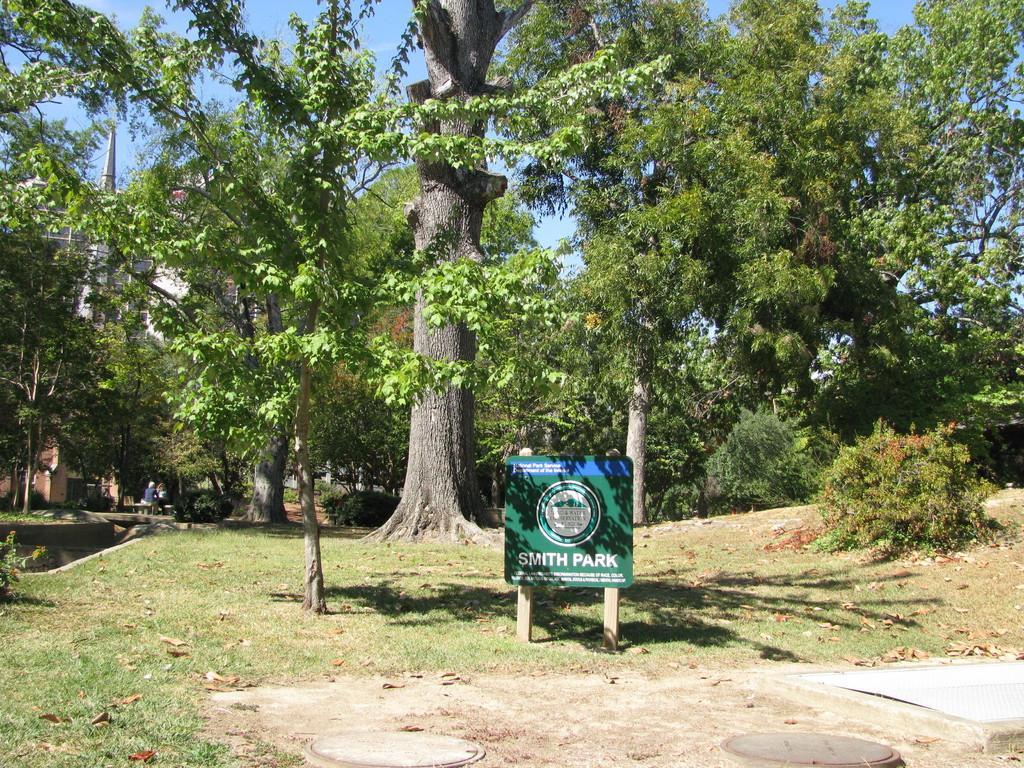How would you summarize this image in a sentence or two? This is an outside view. At the bottom, I can see the grass on the ground. In the middle of the image there is a board on which there is some text. In the background there are many trees. On the left side there is a building and I can see two persons are sitting on a bench and also there is a pond. At the top of the image I can see the sky. 